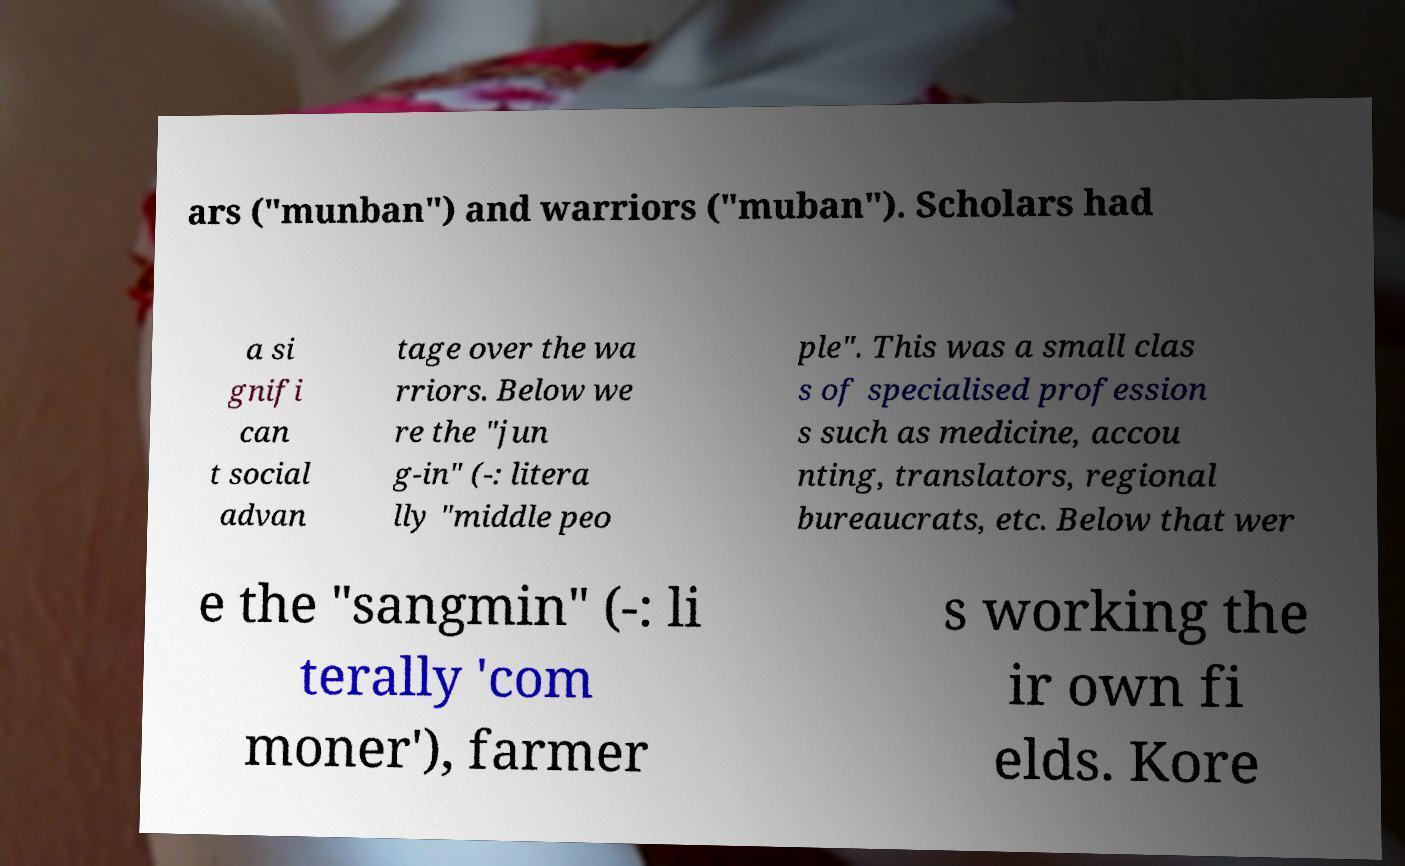There's text embedded in this image that I need extracted. Can you transcribe it verbatim? ars ("munban") and warriors ("muban"). Scholars had a si gnifi can t social advan tage over the wa rriors. Below we re the "jun g-in" (-: litera lly "middle peo ple". This was a small clas s of specialised profession s such as medicine, accou nting, translators, regional bureaucrats, etc. Below that wer e the "sangmin" (-: li terally 'com moner'), farmer s working the ir own fi elds. Kore 